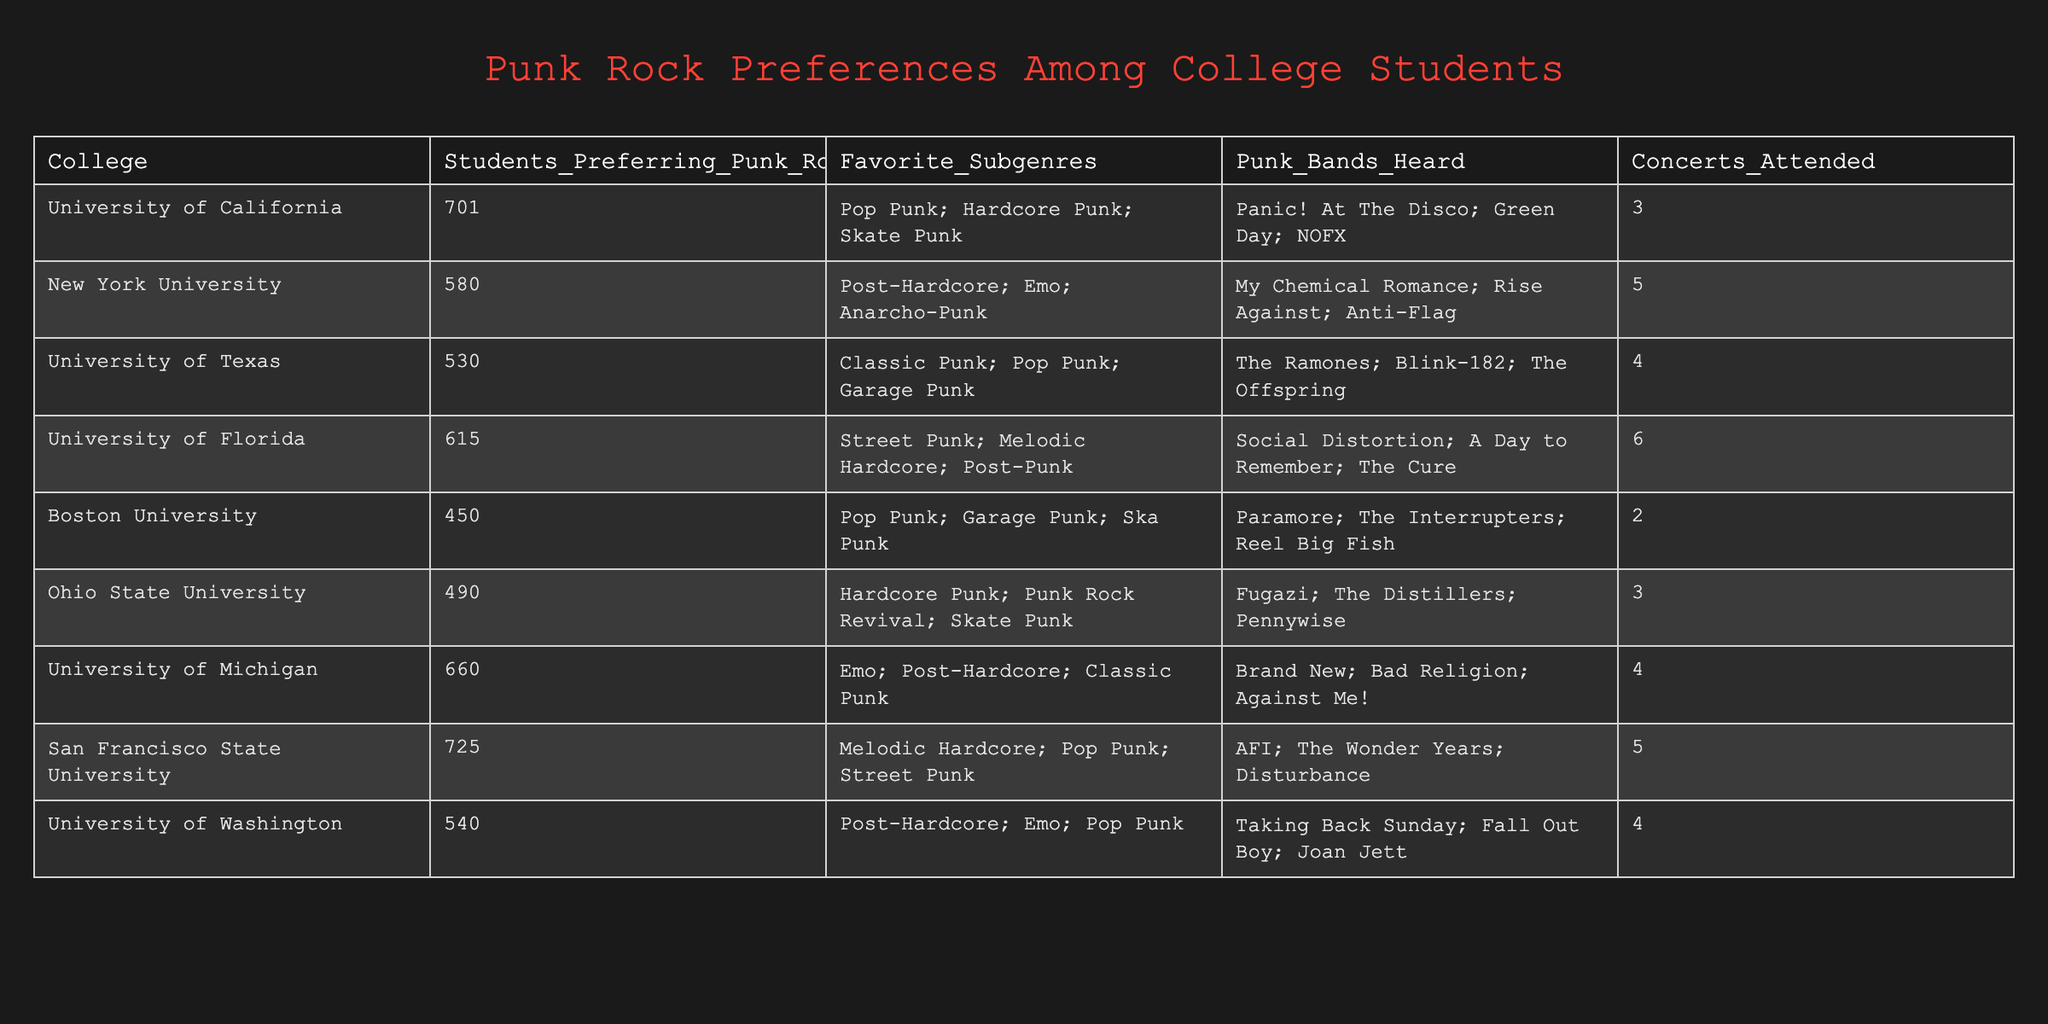What college has the highest number of students preferring punk rock? By looking at the "Students_Preferring_Punk_Rock" column, we can see that San Francisco State University has the highest value of 725 students.
Answer: San Francisco State University How many concerts did students from the University of Florida attend? The "Concerts_Attended" column indicates that students from the University of Florida attended 6 concerts.
Answer: 6 Which favorite subgenre is most common among these colleges? By reviewing the "Favorite_Subgenres" column, Pop Punk appears most frequently in 4 different colleges: University of California, University of Texas, Boston University, and San Francisco State University.
Answer: Pop Punk What is the average number of concerts attended by students across all universities? To find the average, we first sum the total concerts attended (3 + 5 + 4 + 6 + 2 + 3 + 4 + 5 = 32) and then divide by the number of universities (8), which gives us an average of 32/8 = 4.
Answer: 4 Is it true that Ohio State University students prefer Emo as one of their favorite subgenres? Looking at the "Favorite_Subgenres" for Ohio State University, it states Hardcore Punk; Punk Rock Revival; Skate Punk. Emo is not listed here, which means the statement is false.
Answer: No Which college has the least number of students preferring punk rock and what are their favorite subgenres? The college with the least students preferring punk rock is Boston University with 450 students. Their favorite subgenres include Pop Punk, Garage Punk, and Ska Punk.
Answer: Boston University, Pop Punk; Garage Punk; Ska Punk How many different favorite subgenres are mentioned by students at Ohio State University? Ohio State University lists 3 favorite subgenres: Hardcore Punk, Punk Rock Revival, and Skate Punk. Therefore, the total number of different subgenres mentioned is 3.
Answer: 3 What is the total number of students preferring punk rock across all universities combined? By adding up all students from the "Students_Preferring_Punk_Rock" column (701 + 580 + 530 + 615 + 450 + 490 + 660 + 725), we find that the total is 4,751 students.
Answer: 4751 Which universities have students that attend more than 4 concerts? The universities with students attending more than 4 concerts are New York University (5), University of Florida (6), San Francisco State University (5), and University of Michigan (4). Thus, four universities have this characteristic.
Answer: 4 universities 